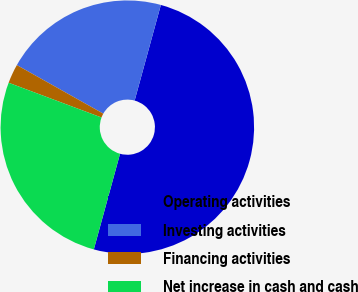<chart> <loc_0><loc_0><loc_500><loc_500><pie_chart><fcel>Operating activities<fcel>Investing activities<fcel>Financing activities<fcel>Net increase in cash and cash<nl><fcel>50.0%<fcel>21.11%<fcel>2.45%<fcel>26.44%<nl></chart> 